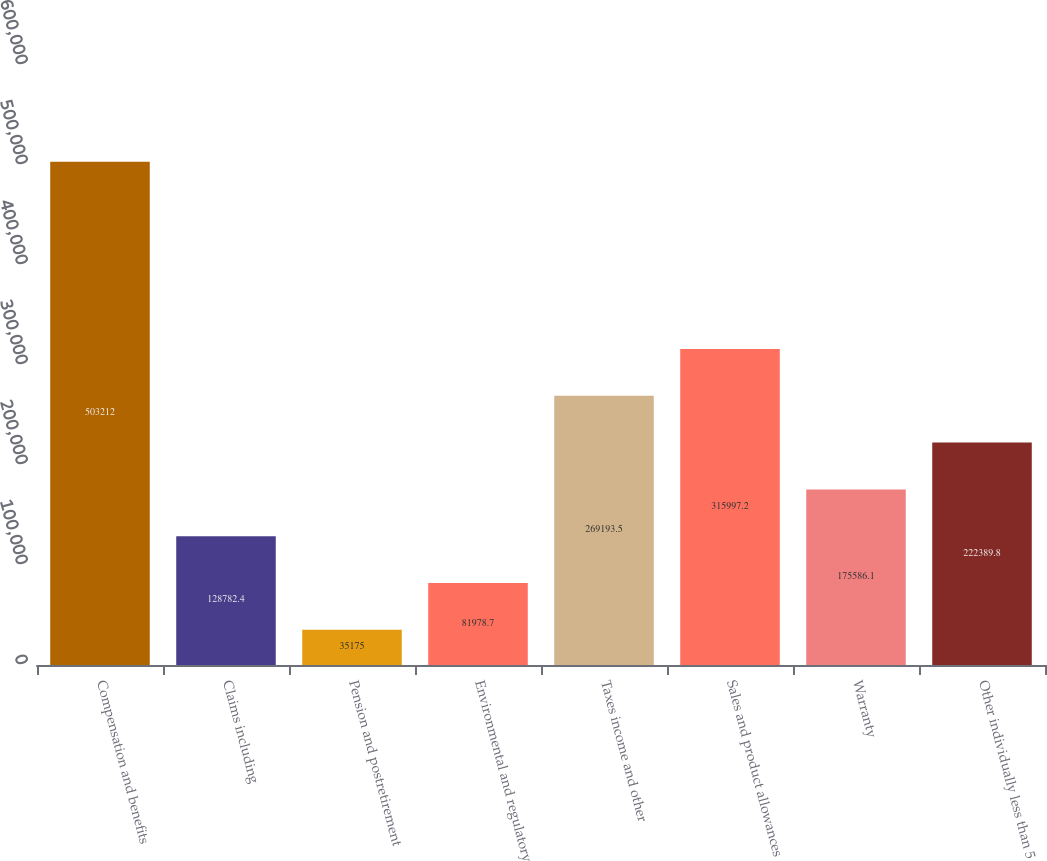<chart> <loc_0><loc_0><loc_500><loc_500><bar_chart><fcel>Compensation and benefits<fcel>Claims including<fcel>Pension and postretirement<fcel>Environmental and regulatory<fcel>Taxes income and other<fcel>Sales and product allowances<fcel>Warranty<fcel>Other individually less than 5<nl><fcel>503212<fcel>128782<fcel>35175<fcel>81978.7<fcel>269194<fcel>315997<fcel>175586<fcel>222390<nl></chart> 